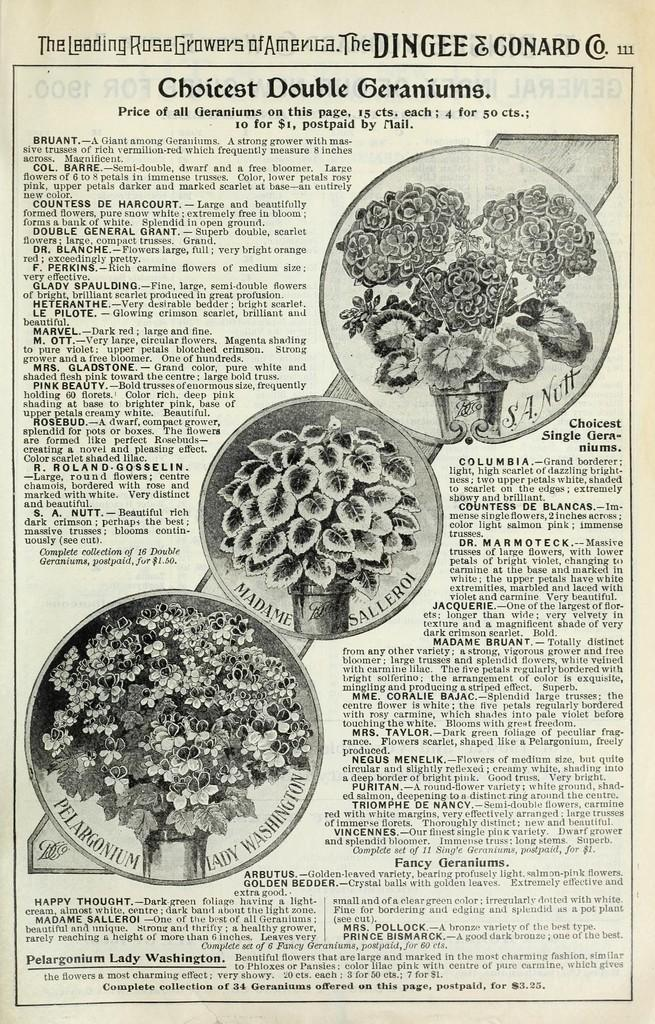What is the main object in the image? There is a newspaper in the image. What can be found on the newspaper? The newspaper has printed text. Are there any images on the newspaper? Yes, there are images of flower pots on the newspaper. What type of vegetable is being served by the band in the image? There is no band or vegetable present in the image; it only features a newspaper with images of flower pots. 